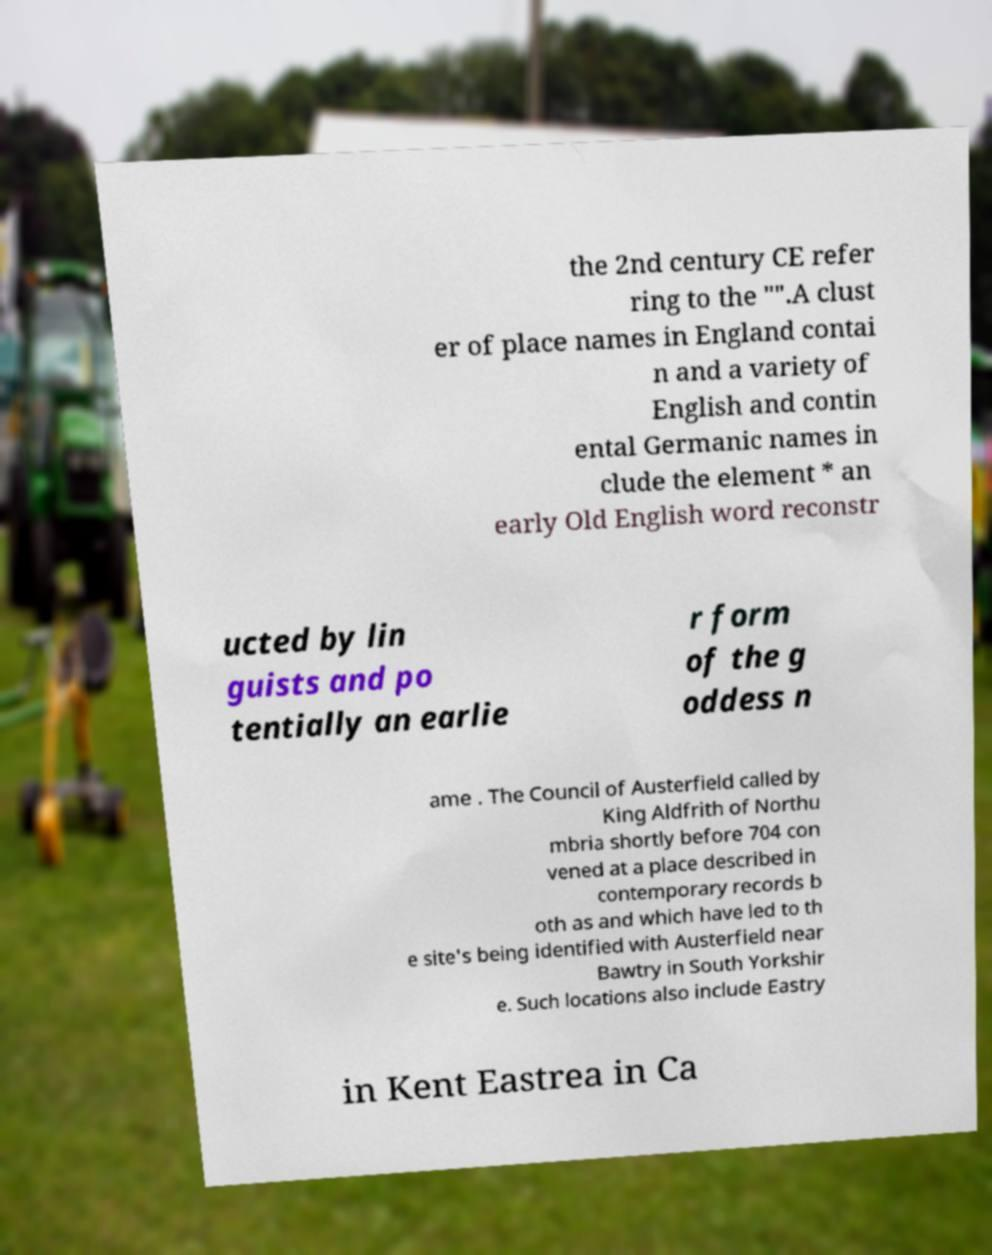Can you read and provide the text displayed in the image?This photo seems to have some interesting text. Can you extract and type it out for me? the 2nd century CE refer ring to the "".A clust er of place names in England contai n and a variety of English and contin ental Germanic names in clude the element * an early Old English word reconstr ucted by lin guists and po tentially an earlie r form of the g oddess n ame . The Council of Austerfield called by King Aldfrith of Northu mbria shortly before 704 con vened at a place described in contemporary records b oth as and which have led to th e site's being identified with Austerfield near Bawtry in South Yorkshir e. Such locations also include Eastry in Kent Eastrea in Ca 